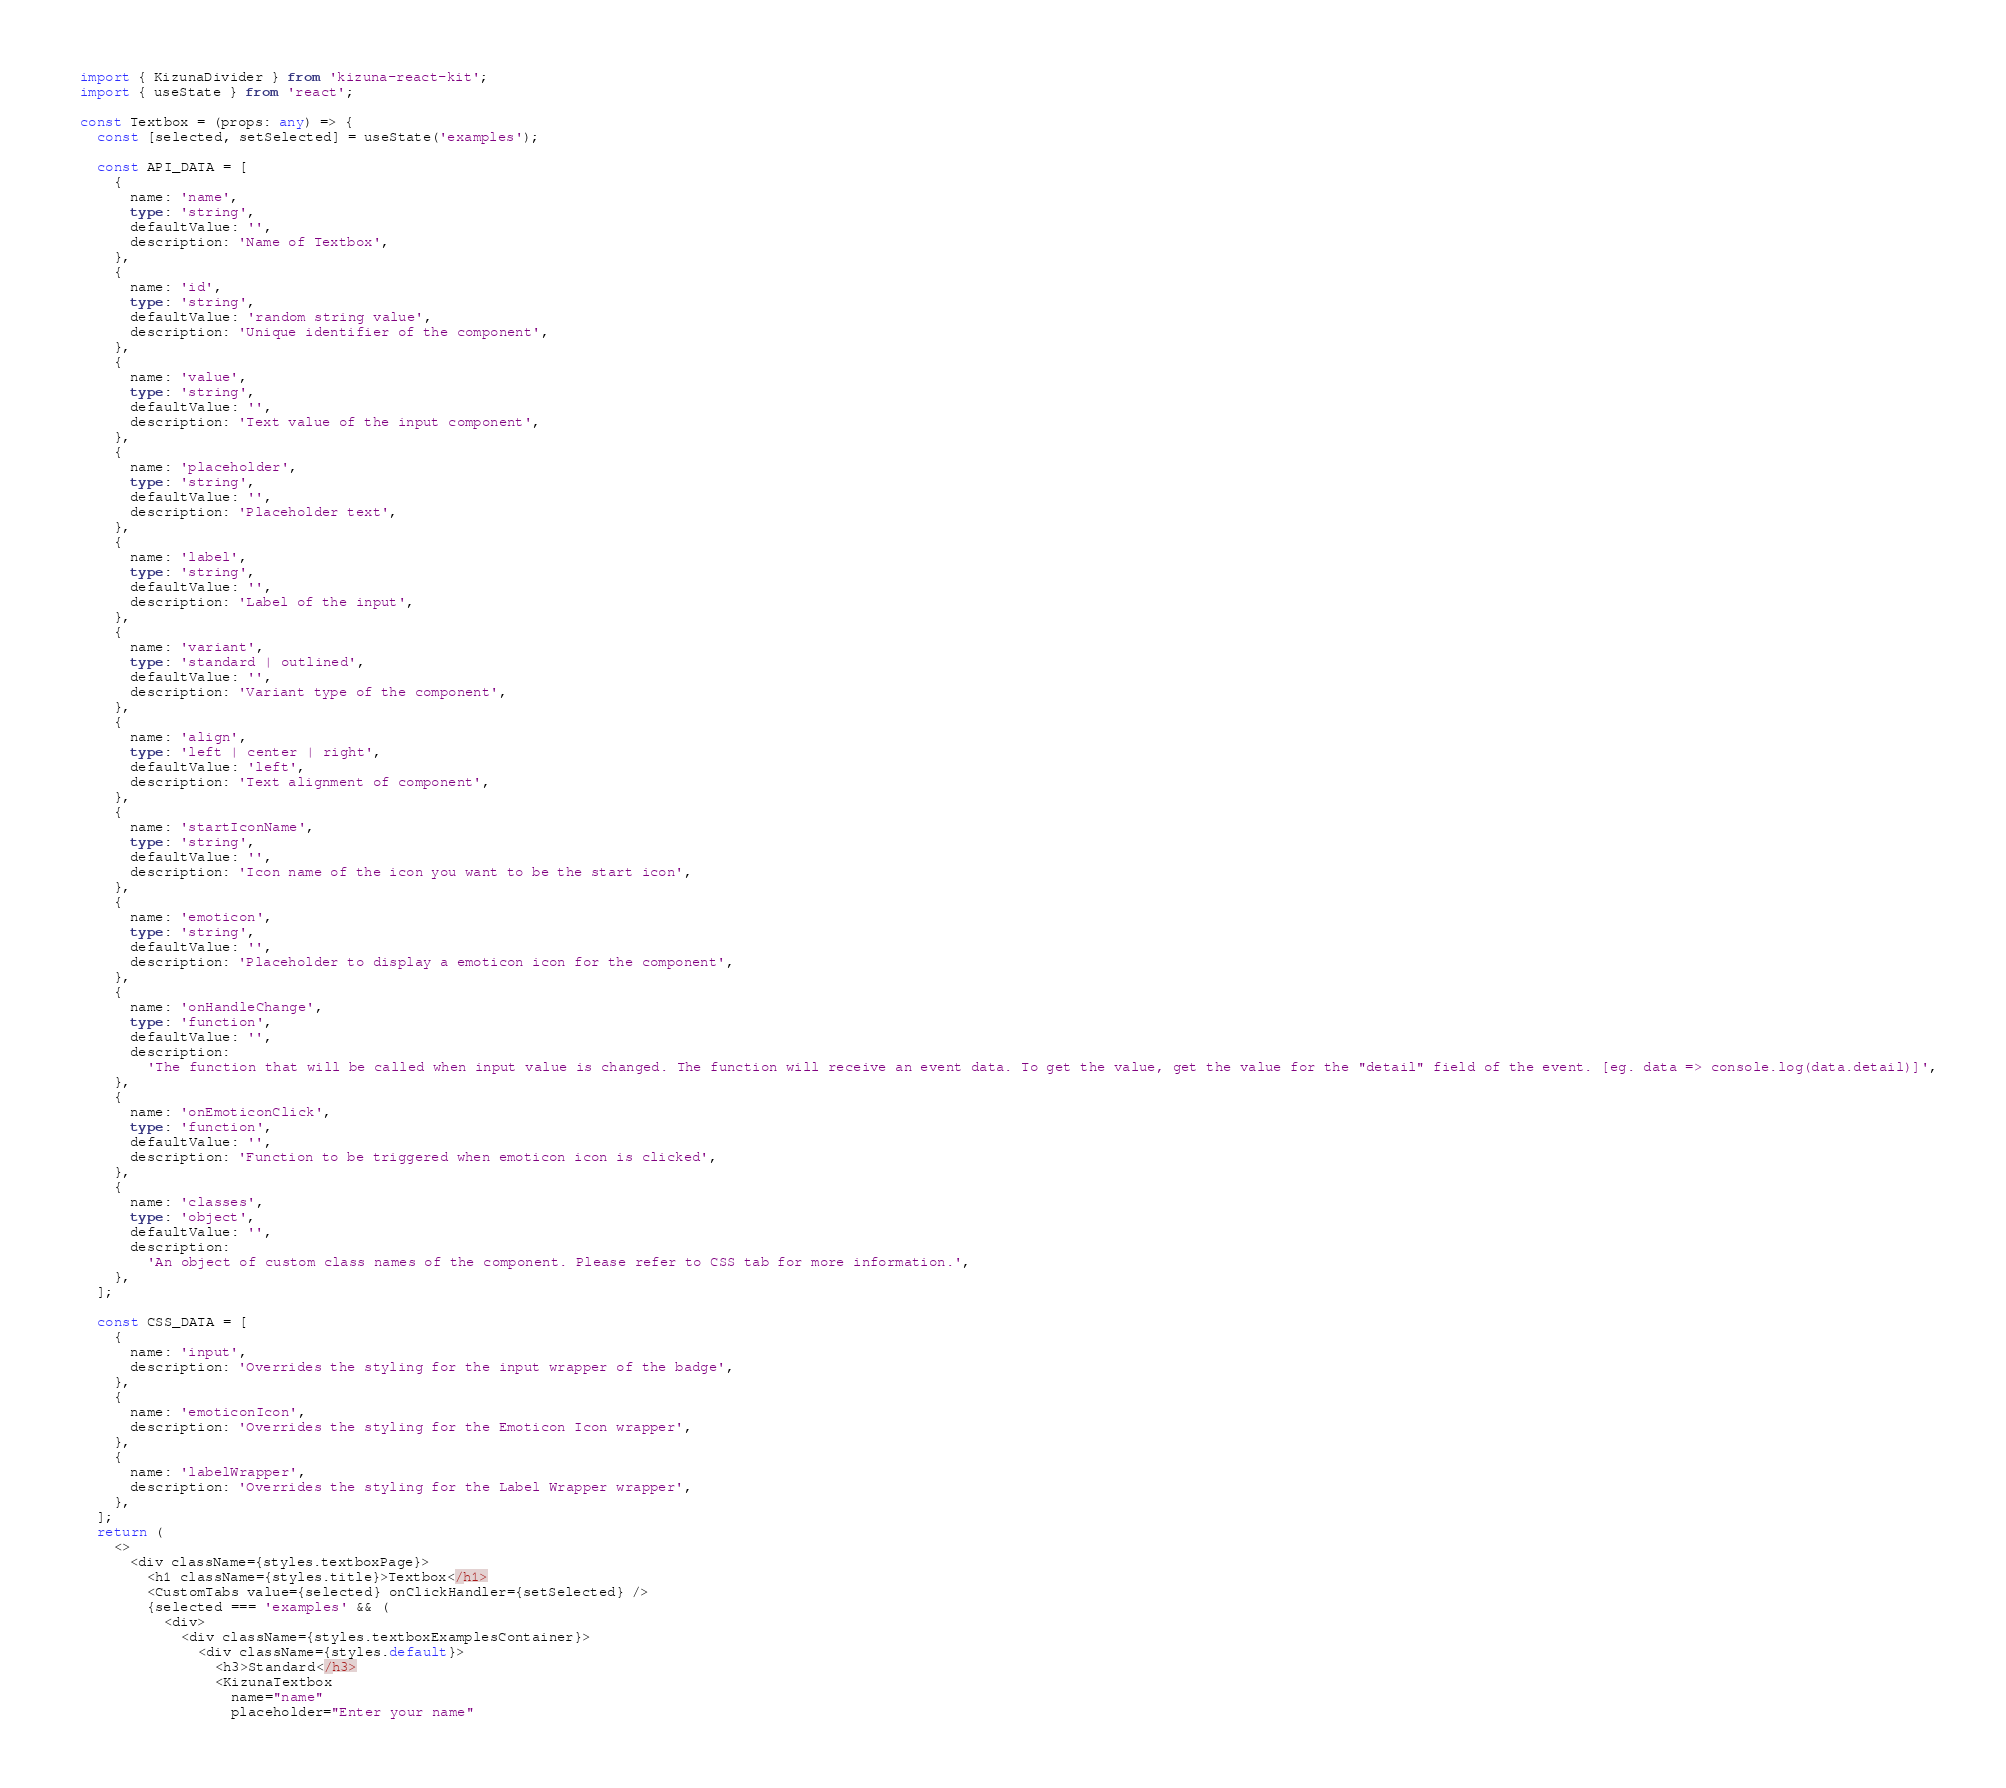Convert code to text. <code><loc_0><loc_0><loc_500><loc_500><_TypeScript_>import { KizunaDivider } from 'kizuna-react-kit';
import { useState } from 'react';

const Textbox = (props: any) => {
  const [selected, setSelected] = useState('examples');

  const API_DATA = [
    {
      name: 'name',
      type: 'string',
      defaultValue: '',
      description: 'Name of Textbox',
    },
    {
      name: 'id',
      type: 'string',
      defaultValue: 'random string value',
      description: 'Unique identifier of the component',
    },
    {
      name: 'value',
      type: 'string',
      defaultValue: '',
      description: 'Text value of the input component',
    },
    {
      name: 'placeholder',
      type: 'string',
      defaultValue: '',
      description: 'Placeholder text',
    },
    {
      name: 'label',
      type: 'string',
      defaultValue: '',
      description: 'Label of the input',
    },
    {
      name: 'variant',
      type: 'standard | outlined',
      defaultValue: '',
      description: 'Variant type of the component',
    },
    {
      name: 'align',
      type: 'left | center | right',
      defaultValue: 'left',
      description: 'Text alignment of component',
    },
    {
      name: 'startIconName',
      type: 'string',
      defaultValue: '',
      description: 'Icon name of the icon you want to be the start icon',
    },
    {
      name: 'emoticon',
      type: 'string',
      defaultValue: '',
      description: 'Placeholder to display a emoticon icon for the component',
    },
    {
      name: 'onHandleChange',
      type: 'function',
      defaultValue: '',
      description:
        'The function that will be called when input value is changed. The function will receive an event data. To get the value, get the value for the "detail" field of the event. [eg. data => console.log(data.detail)]',
    },
    {
      name: 'onEmoticonClick',
      type: 'function',
      defaultValue: '',
      description: 'Function to be triggered when emoticon icon is clicked',
    },
    {
      name: 'classes',
      type: 'object',
      defaultValue: '',
      description:
        'An object of custom class names of the component. Please refer to CSS tab for more information.',
    },
  ];

  const CSS_DATA = [
    {
      name: 'input',
      description: 'Overrides the styling for the input wrapper of the badge',
    },
    {
      name: 'emoticonIcon',
      description: 'Overrides the styling for the Emoticon Icon wrapper',
    },
    {
      name: 'labelWrapper',
      description: 'Overrides the styling for the Label Wrapper wrapper',
    },
  ];
  return (
    <>
      <div className={styles.textboxPage}>
        <h1 className={styles.title}>Textbox</h1>
        <CustomTabs value={selected} onClickHandler={setSelected} />
        {selected === 'examples' && (
          <div>
            <div className={styles.textboxExamplesContainer}>
              <div className={styles.default}>
                <h3>Standard</h3>
                <KizunaTextbox
                  name="name"
                  placeholder="Enter your name"</code> 